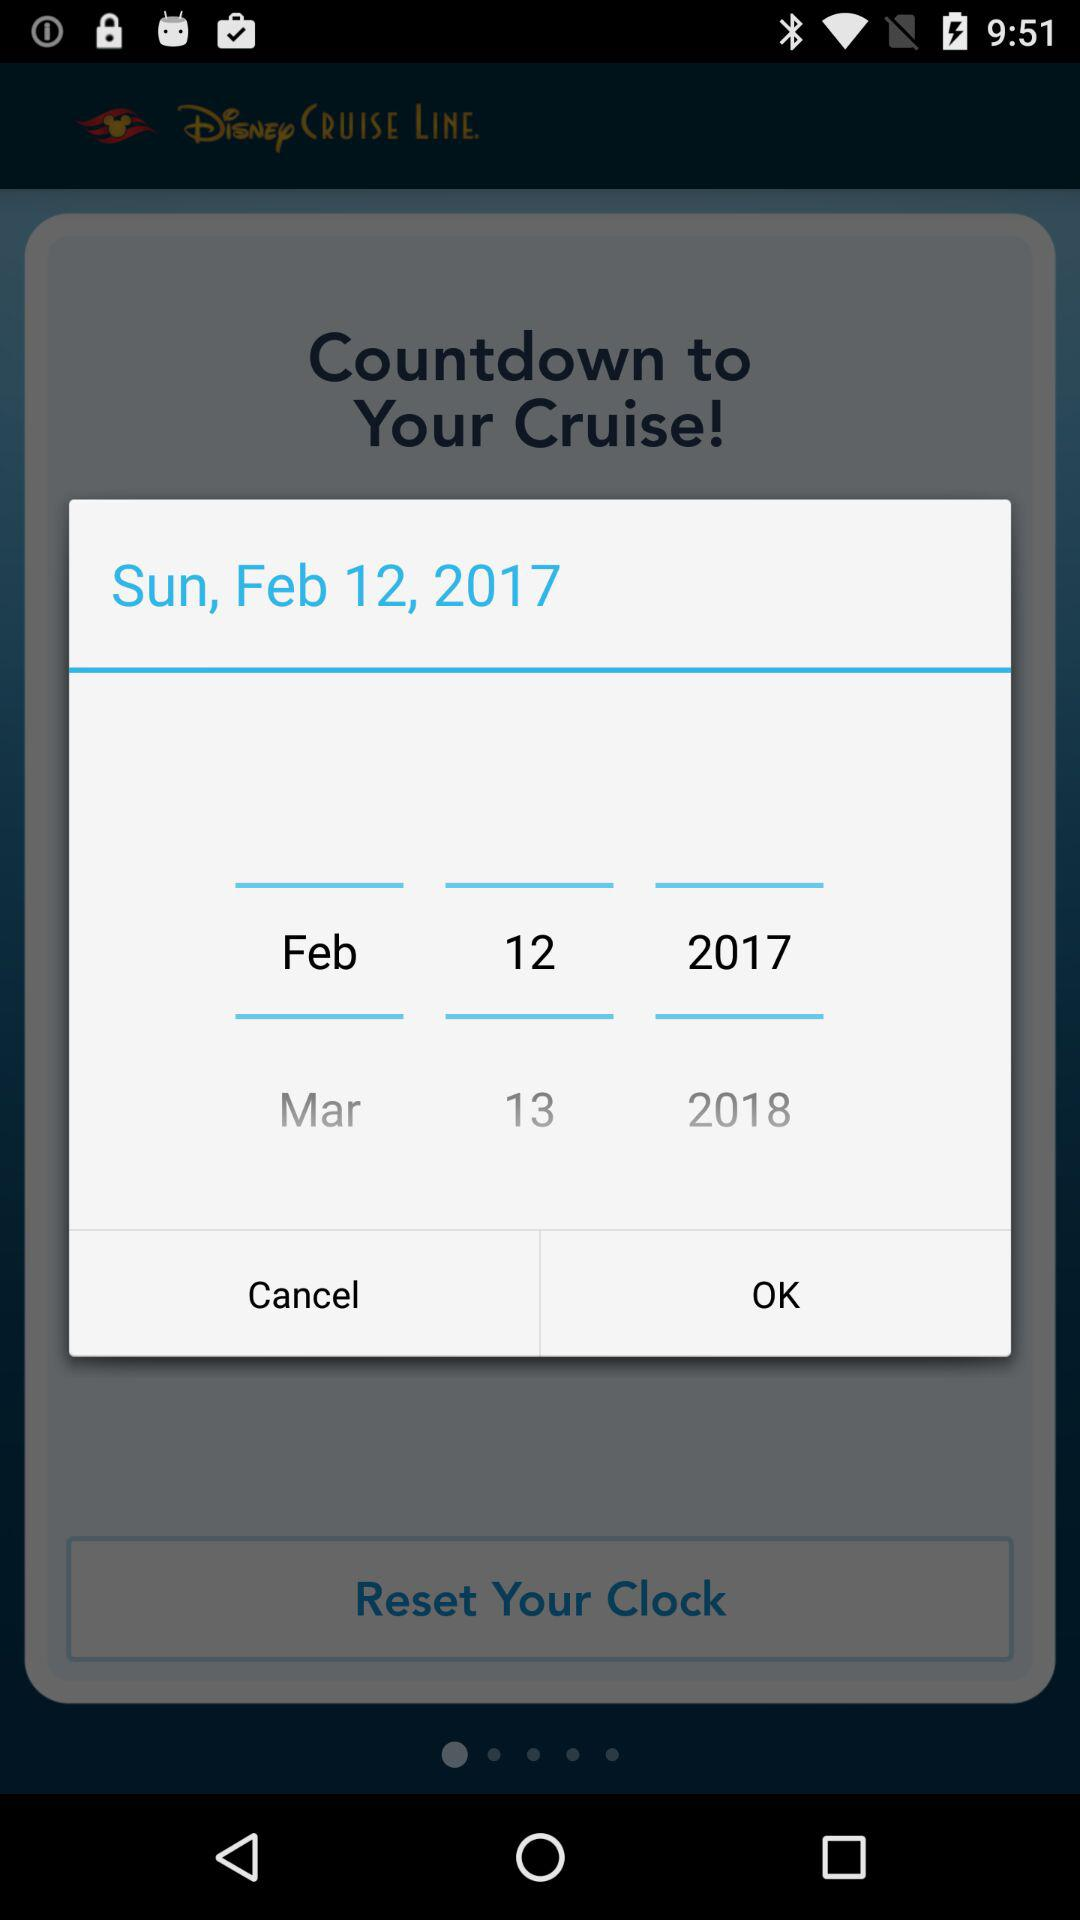What is the selected date? The selected date is Sunday, February 12, 2017. 